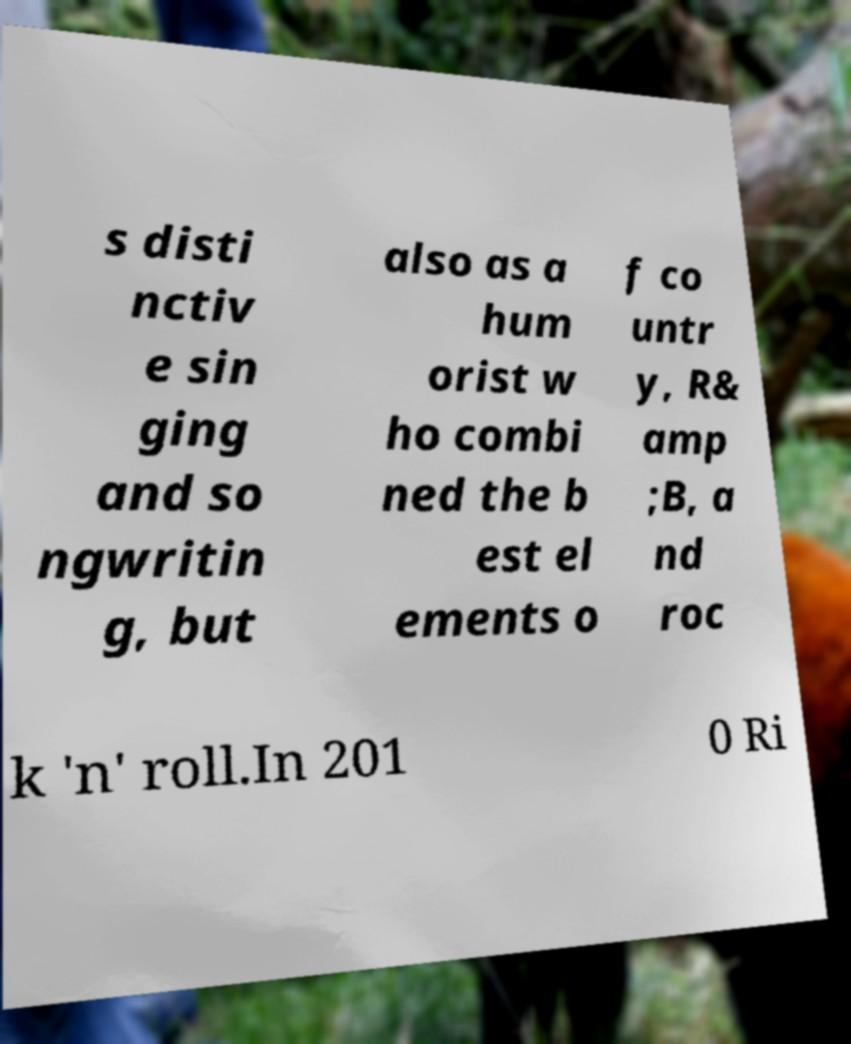There's text embedded in this image that I need extracted. Can you transcribe it verbatim? s disti nctiv e sin ging and so ngwritin g, but also as a hum orist w ho combi ned the b est el ements o f co untr y, R& amp ;B, a nd roc k 'n' roll.In 201 0 Ri 